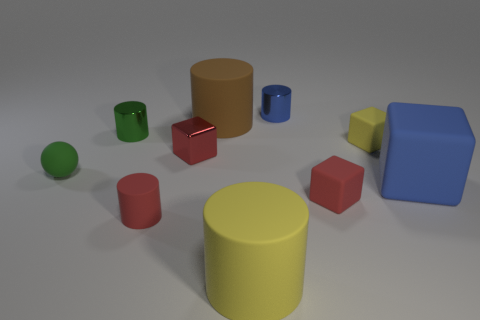Subtract all large yellow cylinders. How many cylinders are left? 4 Subtract all brown cylinders. How many cylinders are left? 4 Subtract all cyan cylinders. Subtract all blue balls. How many cylinders are left? 5 Subtract all blocks. How many objects are left? 6 Add 6 purple metallic spheres. How many purple metallic spheres exist? 6 Subtract 1 yellow blocks. How many objects are left? 9 Subtract all tiny brown metal cylinders. Subtract all matte cubes. How many objects are left? 7 Add 2 small blue objects. How many small blue objects are left? 3 